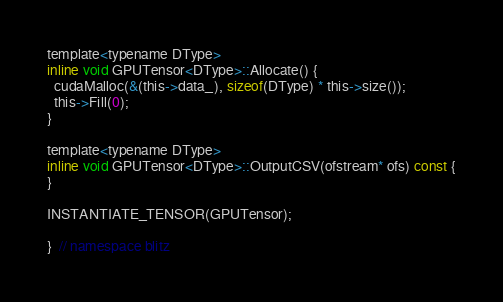Convert code to text. <code><loc_0><loc_0><loc_500><loc_500><_Cuda_>template<typename DType>
inline void GPUTensor<DType>::Allocate() {
  cudaMalloc(&(this->data_), sizeof(DType) * this->size());
  this->Fill(0);
}

template<typename DType>
inline void GPUTensor<DType>::OutputCSV(ofstream* ofs) const {
}

INSTANTIATE_TENSOR(GPUTensor);

}  // namespace blitz
</code> 